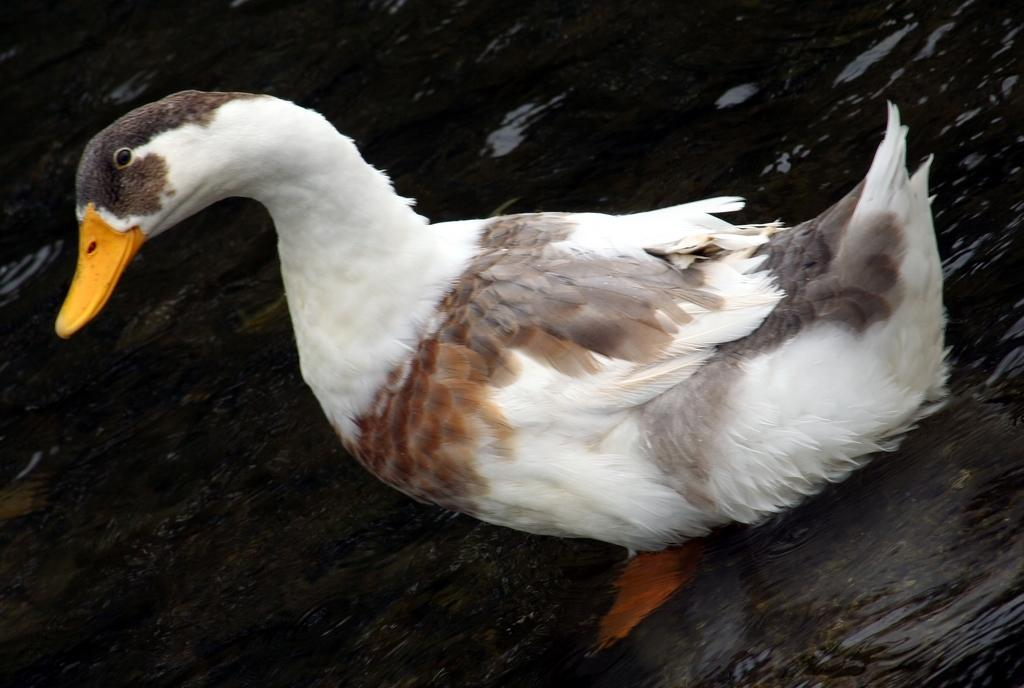What animal is present in the image? There is a duck in the image. Where is the duck located? The duck is in the water. What type of boat can be seen in the image? There is no boat present in the image; it only features a duck in the water. Where is the lunchroom located in the image? There is no lunchroom present in the image; it only features a duck in the water. 